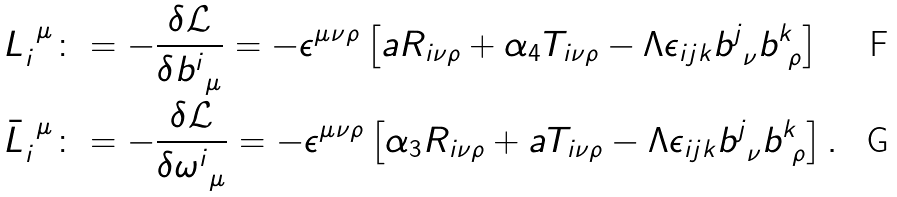Convert formula to latex. <formula><loc_0><loc_0><loc_500><loc_500>L _ { i } ^ { \ \mu } & \colon = - \frac { \delta \mathcal { L } } { \delta b ^ { i } _ { \ \mu } } = - \epsilon ^ { \mu \nu \rho } \left [ a R _ { i \nu \rho } + \alpha _ { 4 } T _ { i \nu \rho } - \Lambda \epsilon _ { i j k } b ^ { j } _ { \ \nu } b ^ { k } _ { \ \rho } \right ] \\ \bar { L } _ { i } ^ { \ \mu } & \colon = - \frac { \delta \mathcal { L } } { \delta \omega ^ { i } _ { \ \mu } } = - \epsilon ^ { \mu \nu \rho } \left [ \alpha _ { 3 } R _ { i \nu \rho } + a T _ { i \nu \rho } - \Lambda \epsilon _ { i j k } b ^ { j } _ { \ \nu } b ^ { k } _ { \ \rho } \right ] .</formula> 